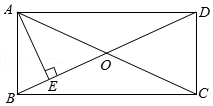Can you explain why the diagonals BD and AC are significant in a rectangle? In a rectangle, the diagonals AC and BD play significant roles. They bisect each other, meaning each diagonal splits the other into two equal halves. This property comes from the symmetrical nature of rectangles. Additionally, the diagonals are equal in length, which is unique to shapes like rectangles and squares within the family of quadrilaterals. This equality and bisecting property can assist in solving complex geometric problems and proofs related to the rectangle. 